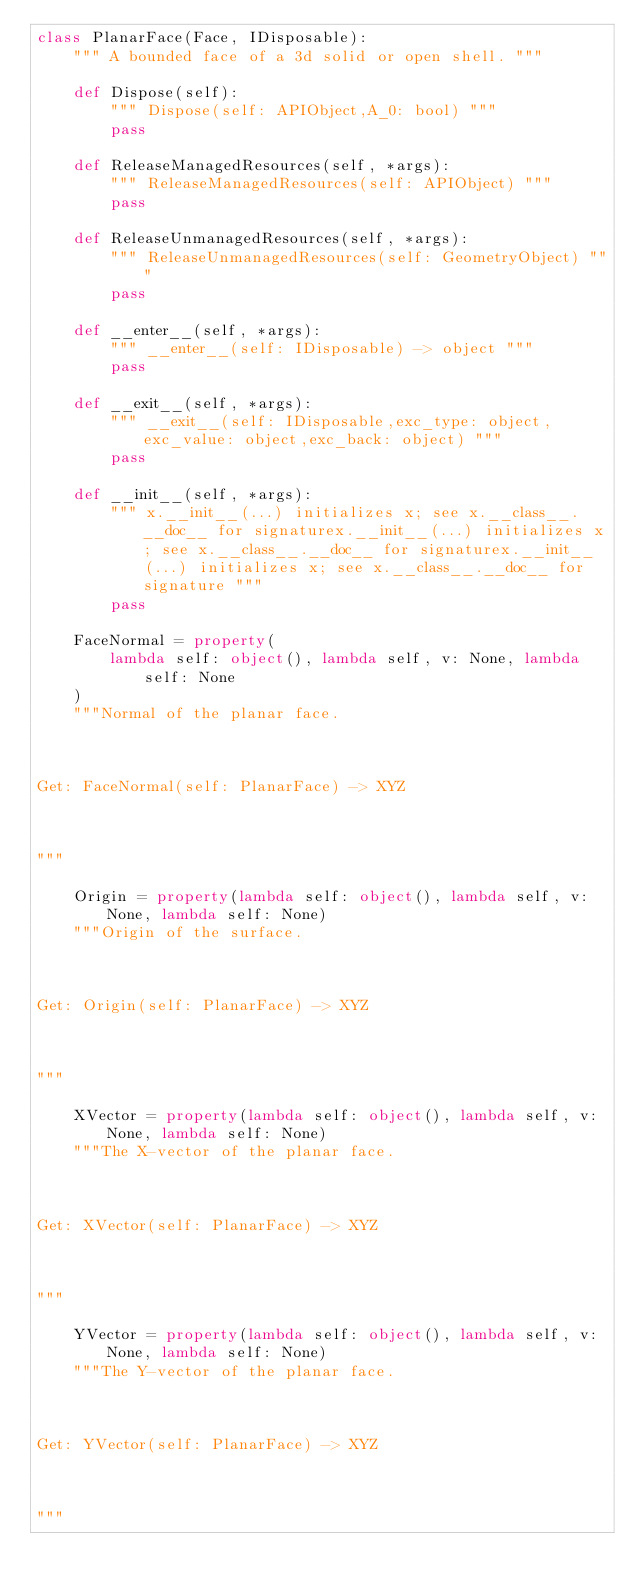Convert code to text. <code><loc_0><loc_0><loc_500><loc_500><_Python_>class PlanarFace(Face, IDisposable):
    """ A bounded face of a 3d solid or open shell. """

    def Dispose(self):
        """ Dispose(self: APIObject,A_0: bool) """
        pass

    def ReleaseManagedResources(self, *args):
        """ ReleaseManagedResources(self: APIObject) """
        pass

    def ReleaseUnmanagedResources(self, *args):
        """ ReleaseUnmanagedResources(self: GeometryObject) """
        pass

    def __enter__(self, *args):
        """ __enter__(self: IDisposable) -> object """
        pass

    def __exit__(self, *args):
        """ __exit__(self: IDisposable,exc_type: object,exc_value: object,exc_back: object) """
        pass

    def __init__(self, *args):
        """ x.__init__(...) initializes x; see x.__class__.__doc__ for signaturex.__init__(...) initializes x; see x.__class__.__doc__ for signaturex.__init__(...) initializes x; see x.__class__.__doc__ for signature """
        pass

    FaceNormal = property(
        lambda self: object(), lambda self, v: None, lambda self: None
    )
    """Normal of the planar face.



Get: FaceNormal(self: PlanarFace) -> XYZ



"""

    Origin = property(lambda self: object(), lambda self, v: None, lambda self: None)
    """Origin of the surface.



Get: Origin(self: PlanarFace) -> XYZ



"""

    XVector = property(lambda self: object(), lambda self, v: None, lambda self: None)
    """The X-vector of the planar face.



Get: XVector(self: PlanarFace) -> XYZ



"""

    YVector = property(lambda self: object(), lambda self, v: None, lambda self: None)
    """The Y-vector of the planar face.



Get: YVector(self: PlanarFace) -> XYZ



"""
</code> 